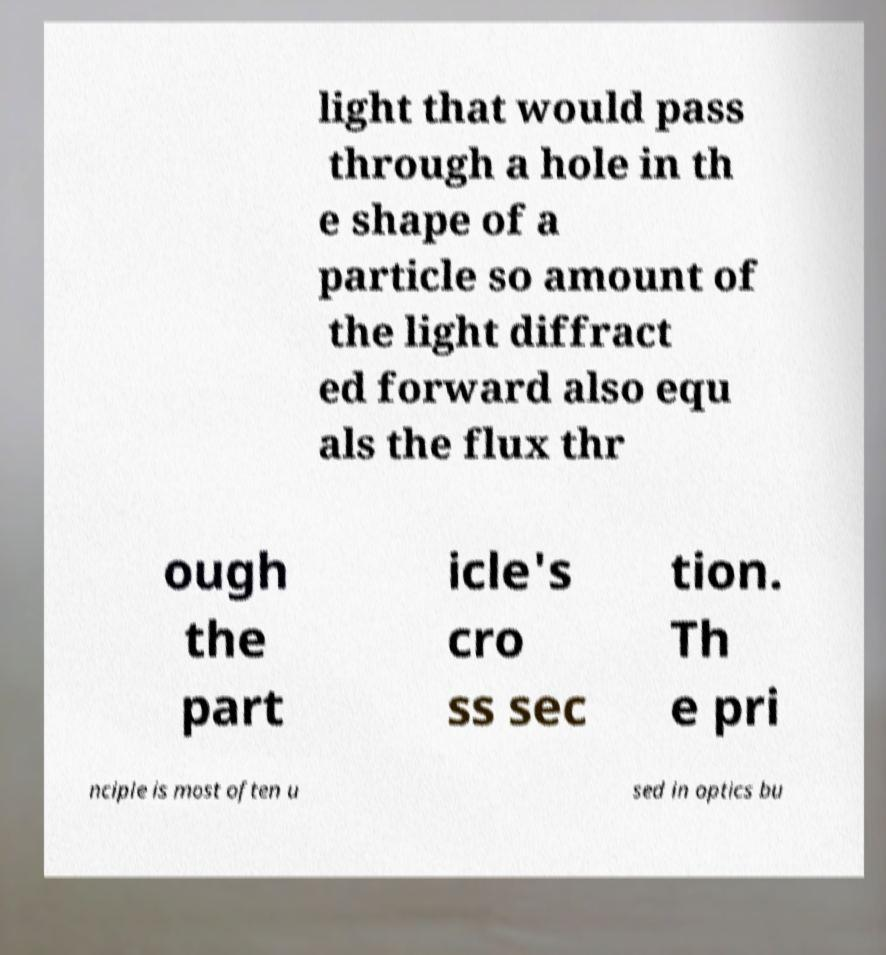Could you assist in decoding the text presented in this image and type it out clearly? light that would pass through a hole in th e shape of a particle so amount of the light diffract ed forward also equ als the flux thr ough the part icle's cro ss sec tion. Th e pri nciple is most often u sed in optics bu 